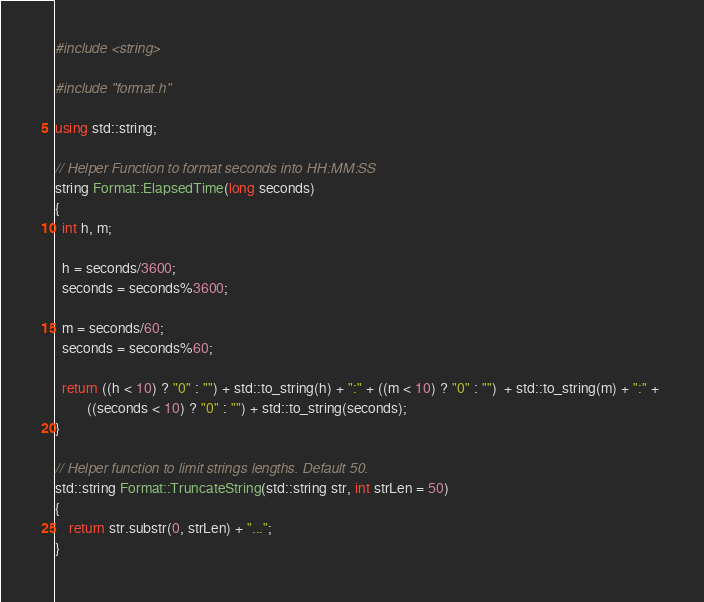<code> <loc_0><loc_0><loc_500><loc_500><_C++_>#include <string>

#include "format.h" 

using std::string;

// Helper Function to format seconds into HH:MM:SS
string Format::ElapsedTime(long seconds) 
{ 
  int h, m;
  
  h = seconds/3600;
  seconds = seconds%3600;
  
  m = seconds/60;
  seconds = seconds%60;
    
  return ((h < 10) ? "0" : "") + std::to_string(h) + ":" + ((m < 10) ? "0" : "")  + std::to_string(m) + ":" + 
         ((seconds < 10) ? "0" : "") + std::to_string(seconds); 
}

// Helper function to limit strings lengths. Default 50.
std::string Format::TruncateString(std::string str, int strLen = 50)
{
    return str.substr(0, strLen) + "...";    
}</code> 